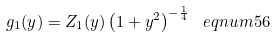<formula> <loc_0><loc_0><loc_500><loc_500>g _ { 1 } ( y ) = Z _ { 1 } ( y ) \left ( 1 + y ^ { 2 } \right ) ^ { - \frac { 1 } { 4 } } \ e q n u m { 5 6 }</formula> 